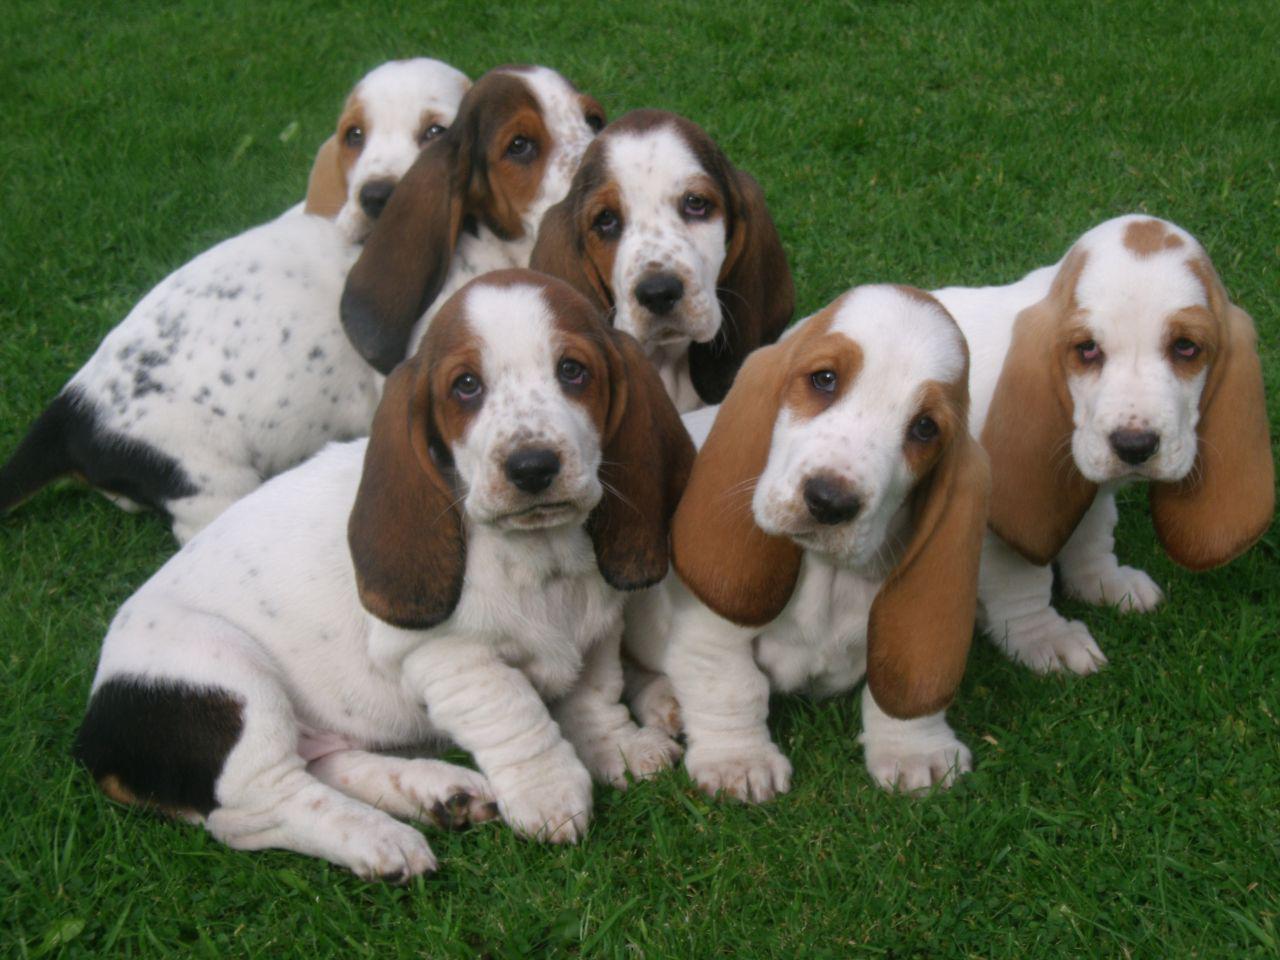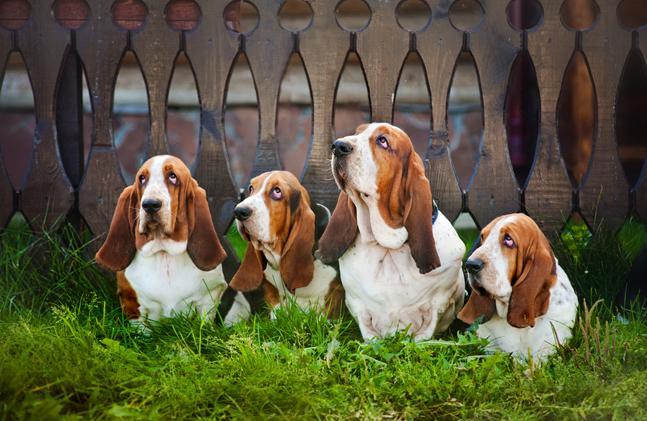The first image is the image on the left, the second image is the image on the right. Analyze the images presented: Is the assertion "there is at least one puppy in the grass" valid? Answer yes or no. Yes. 